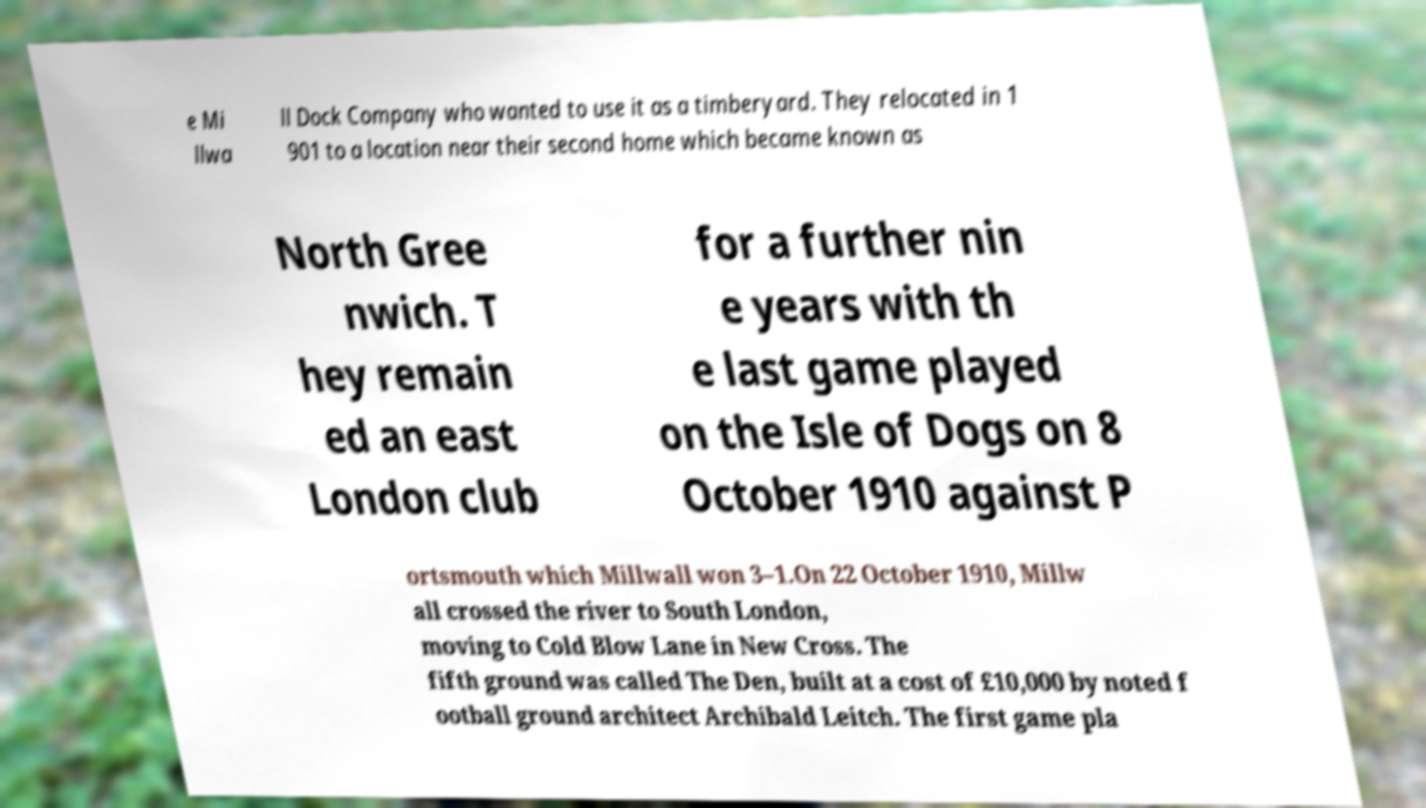Please identify and transcribe the text found in this image. e Mi llwa ll Dock Company who wanted to use it as a timberyard. They relocated in 1 901 to a location near their second home which became known as North Gree nwich. T hey remain ed an east London club for a further nin e years with th e last game played on the Isle of Dogs on 8 October 1910 against P ortsmouth which Millwall won 3–1.On 22 October 1910, Millw all crossed the river to South London, moving to Cold Blow Lane in New Cross. The fifth ground was called The Den, built at a cost of £10,000 by noted f ootball ground architect Archibald Leitch. The first game pla 